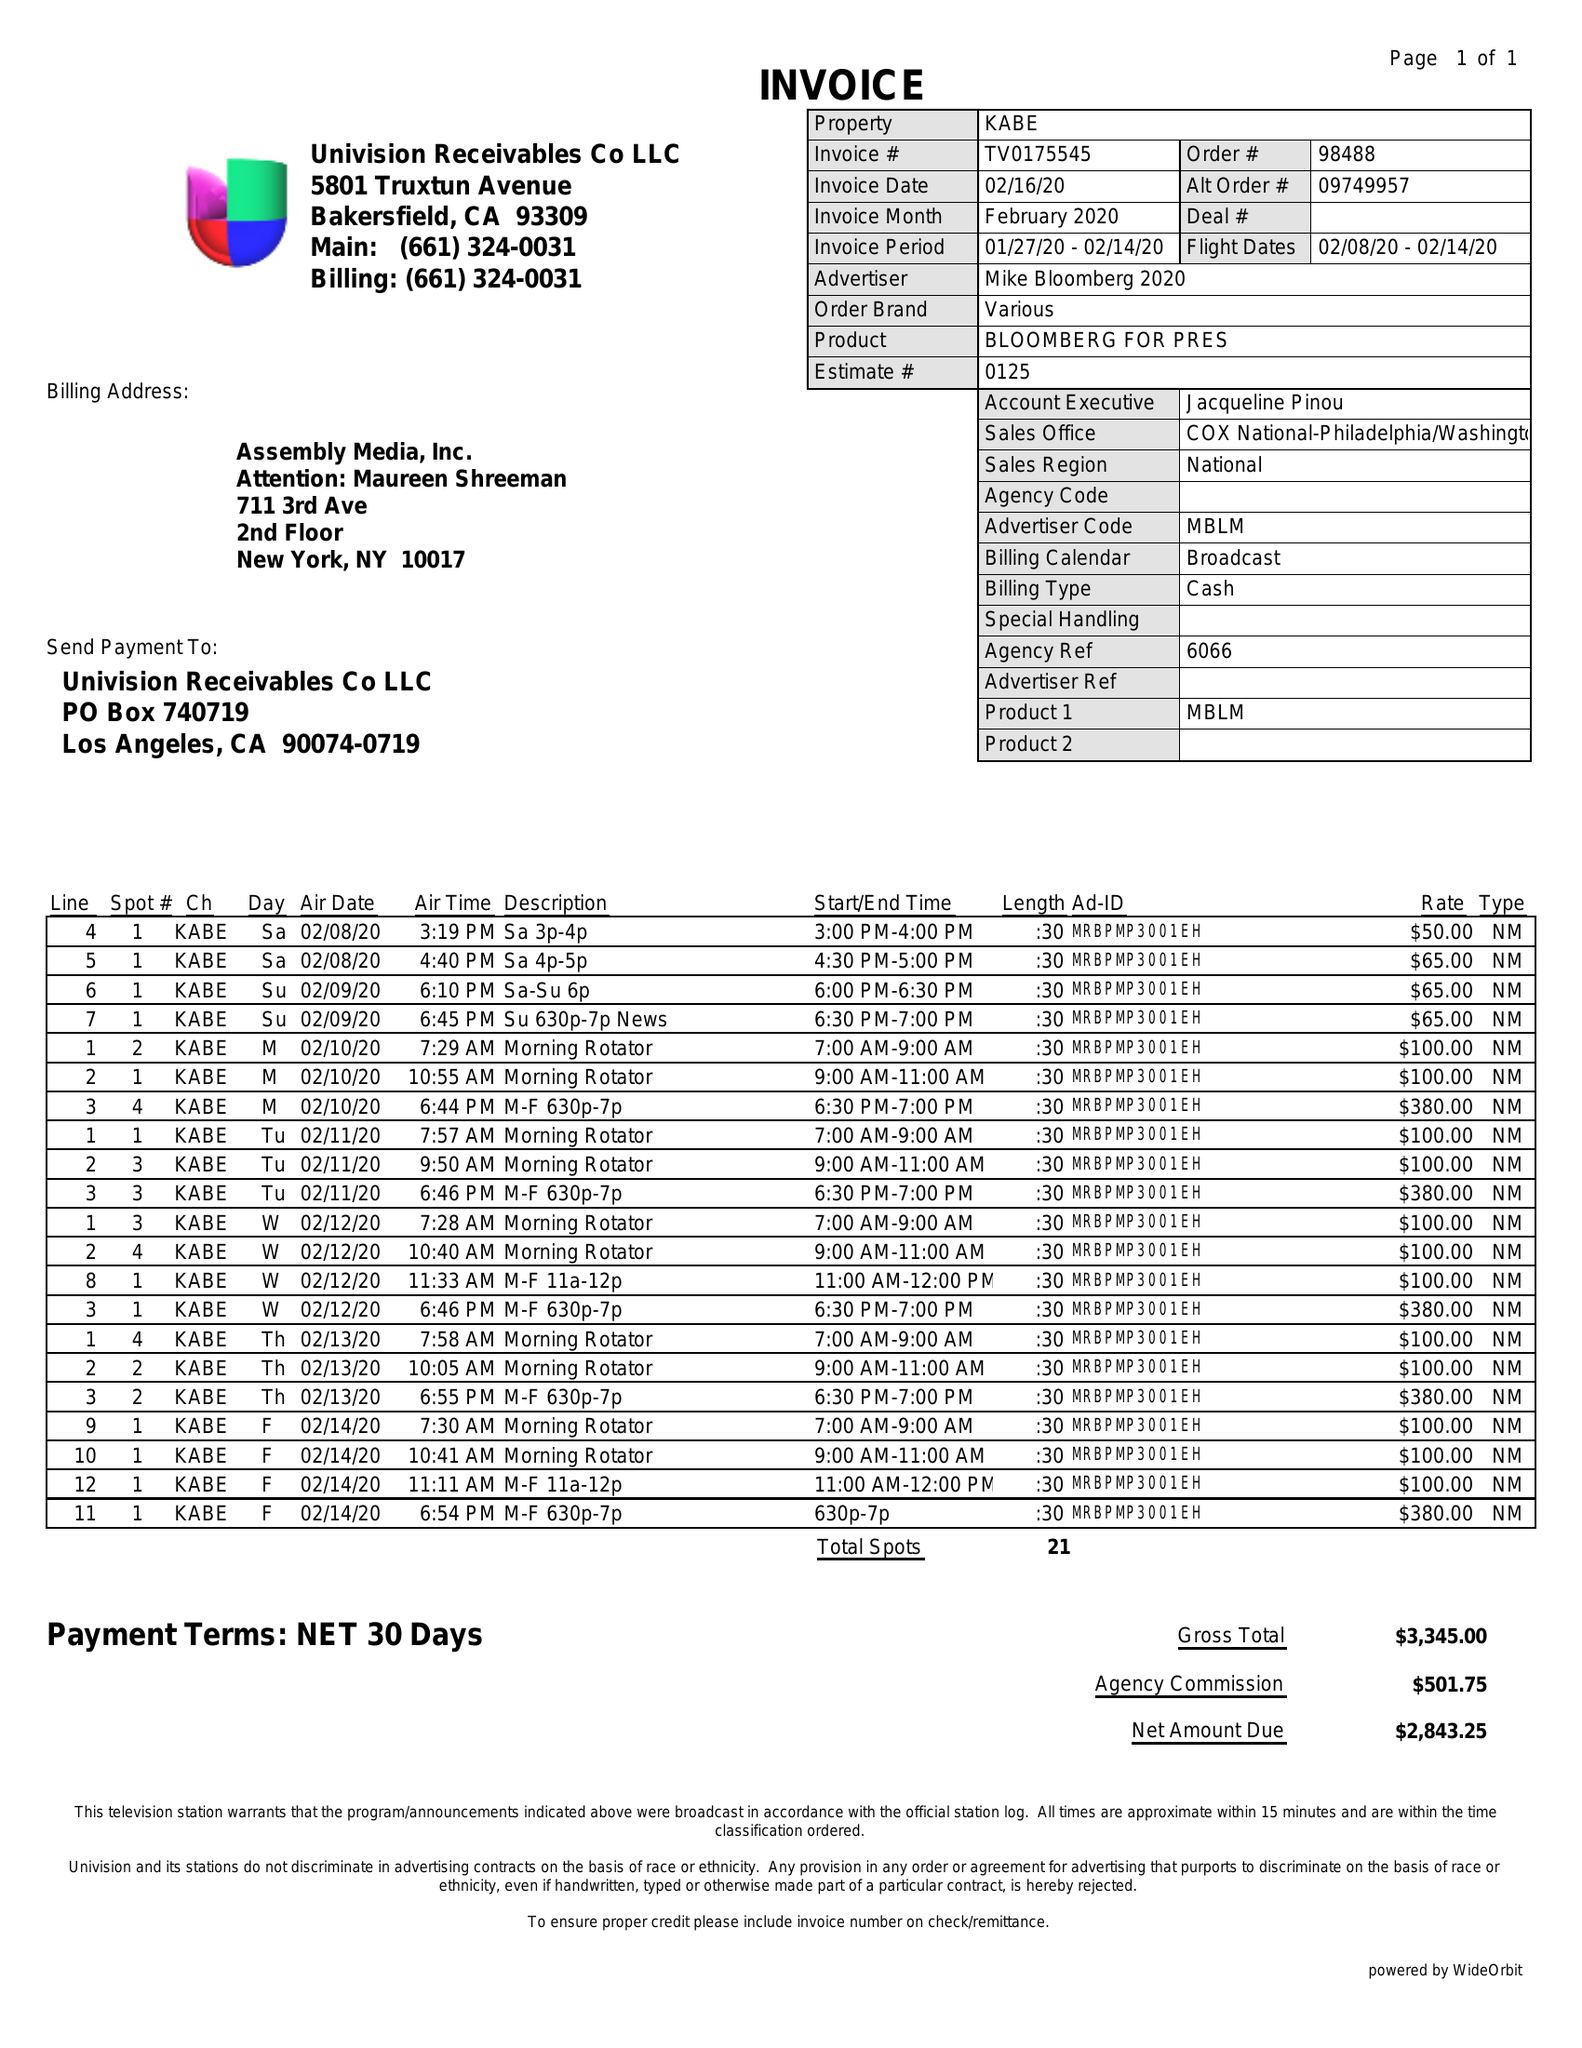What is the value for the contract_num?
Answer the question using a single word or phrase. TV0175545 